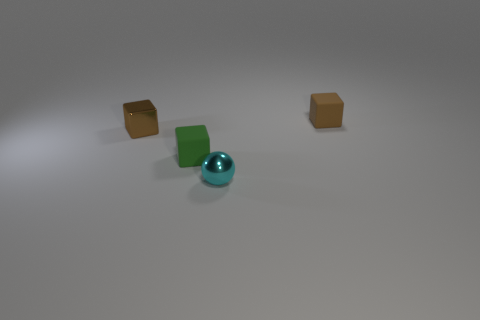The metallic sphere has what size?
Keep it short and to the point. Small. Does the brown shiny object have the same size as the rubber object in front of the brown shiny block?
Give a very brief answer. Yes. The rubber thing in front of the small metallic block that is behind the ball is what color?
Offer a terse response. Green. Are there the same number of small things behind the tiny green thing and matte things right of the sphere?
Keep it short and to the point. No. Is the small object right of the small metal sphere made of the same material as the tiny cyan sphere?
Keep it short and to the point. No. The cube that is to the left of the small brown rubber cube and behind the tiny green thing is what color?
Provide a short and direct response. Brown. How many brown rubber objects are behind the matte object that is behind the tiny green matte block?
Give a very brief answer. 0. There is another tiny brown object that is the same shape as the brown shiny object; what is its material?
Your answer should be compact. Rubber. What color is the metallic sphere?
Make the answer very short. Cyan. How many things are tiny brown cubes or small rubber cubes?
Ensure brevity in your answer.  3. 